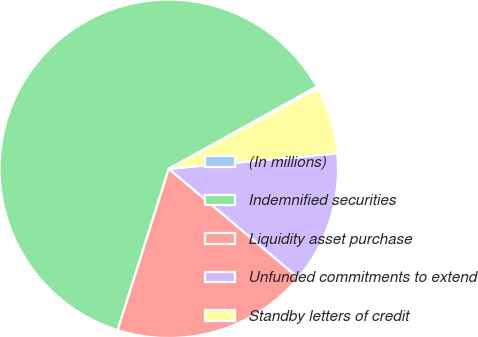Convert chart. <chart><loc_0><loc_0><loc_500><loc_500><pie_chart><fcel>(In millions)<fcel>Indemnified securities<fcel>Liquidity asset purchase<fcel>Unfunded commitments to extend<fcel>Standby letters of credit<nl><fcel>0.22%<fcel>62.03%<fcel>18.76%<fcel>12.58%<fcel>6.4%<nl></chart> 